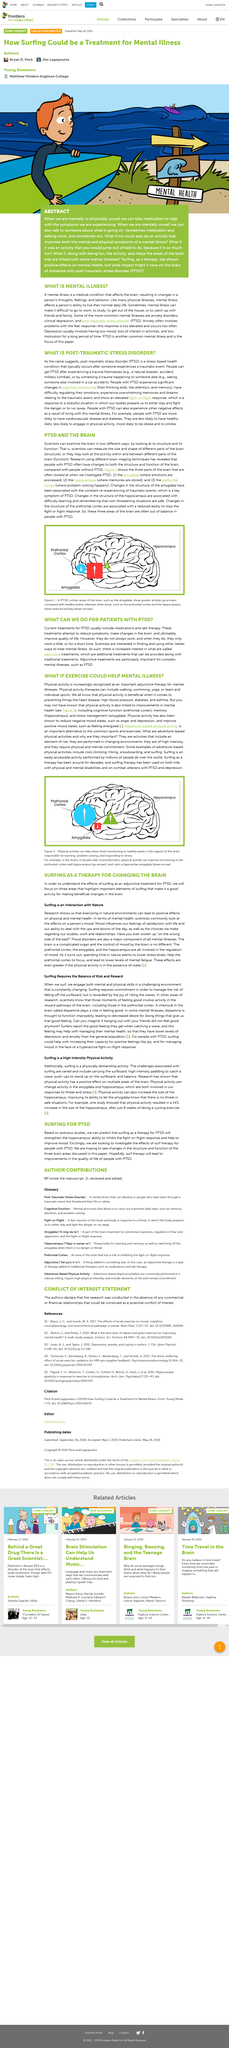Give some essential details in this illustration. Surf therapy has the potential to significantly improve the quality of life for individuals with PTSD by addressing the psychological and emotional impacts of the condition. Surfing as a therapy for PTSD will strengthen the hippocampus' ability to inhibit the fight-or-flight response. Surfing therapy has been shown to have positive effects on mental health. The title of the article is "What is mental illness? Medication and talk therapy are often effective in treating PTSD, but they do not always work and may only provide limited or temporary relief. 